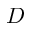Convert formula to latex. <formula><loc_0><loc_0><loc_500><loc_500>D</formula> 